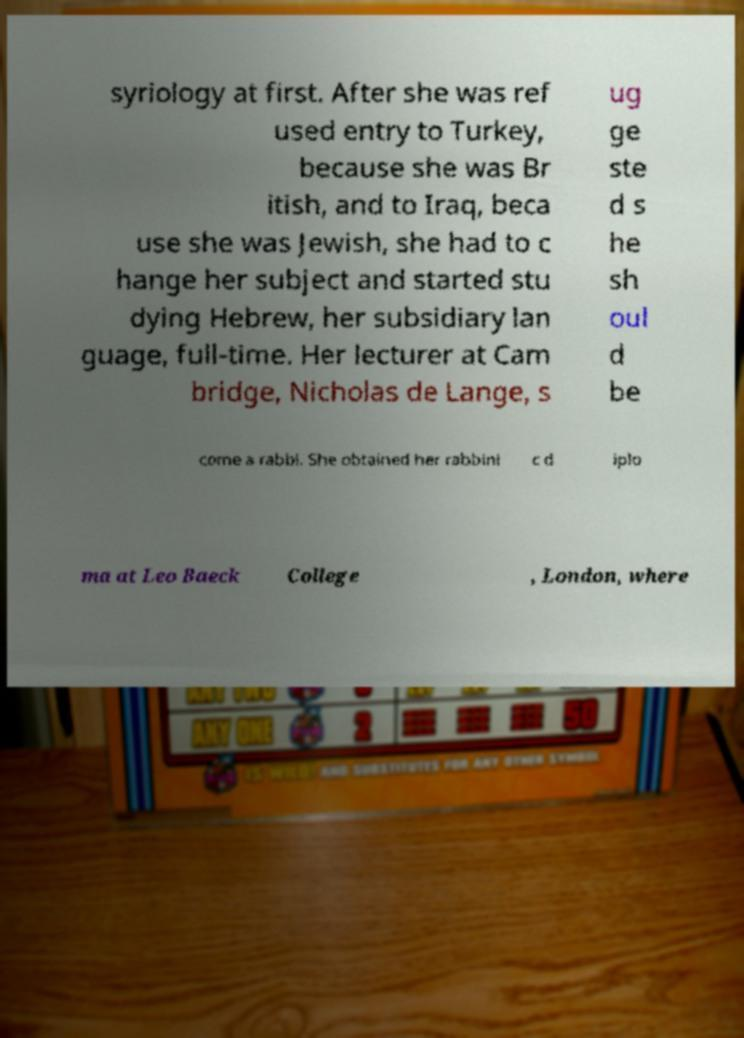I need the written content from this picture converted into text. Can you do that? syriology at first. After she was ref used entry to Turkey, because she was Br itish, and to Iraq, beca use she was Jewish, she had to c hange her subject and started stu dying Hebrew, her subsidiary lan guage, full-time. Her lecturer at Cam bridge, Nicholas de Lange, s ug ge ste d s he sh oul d be come a rabbi. She obtained her rabbini c d iplo ma at Leo Baeck College , London, where 